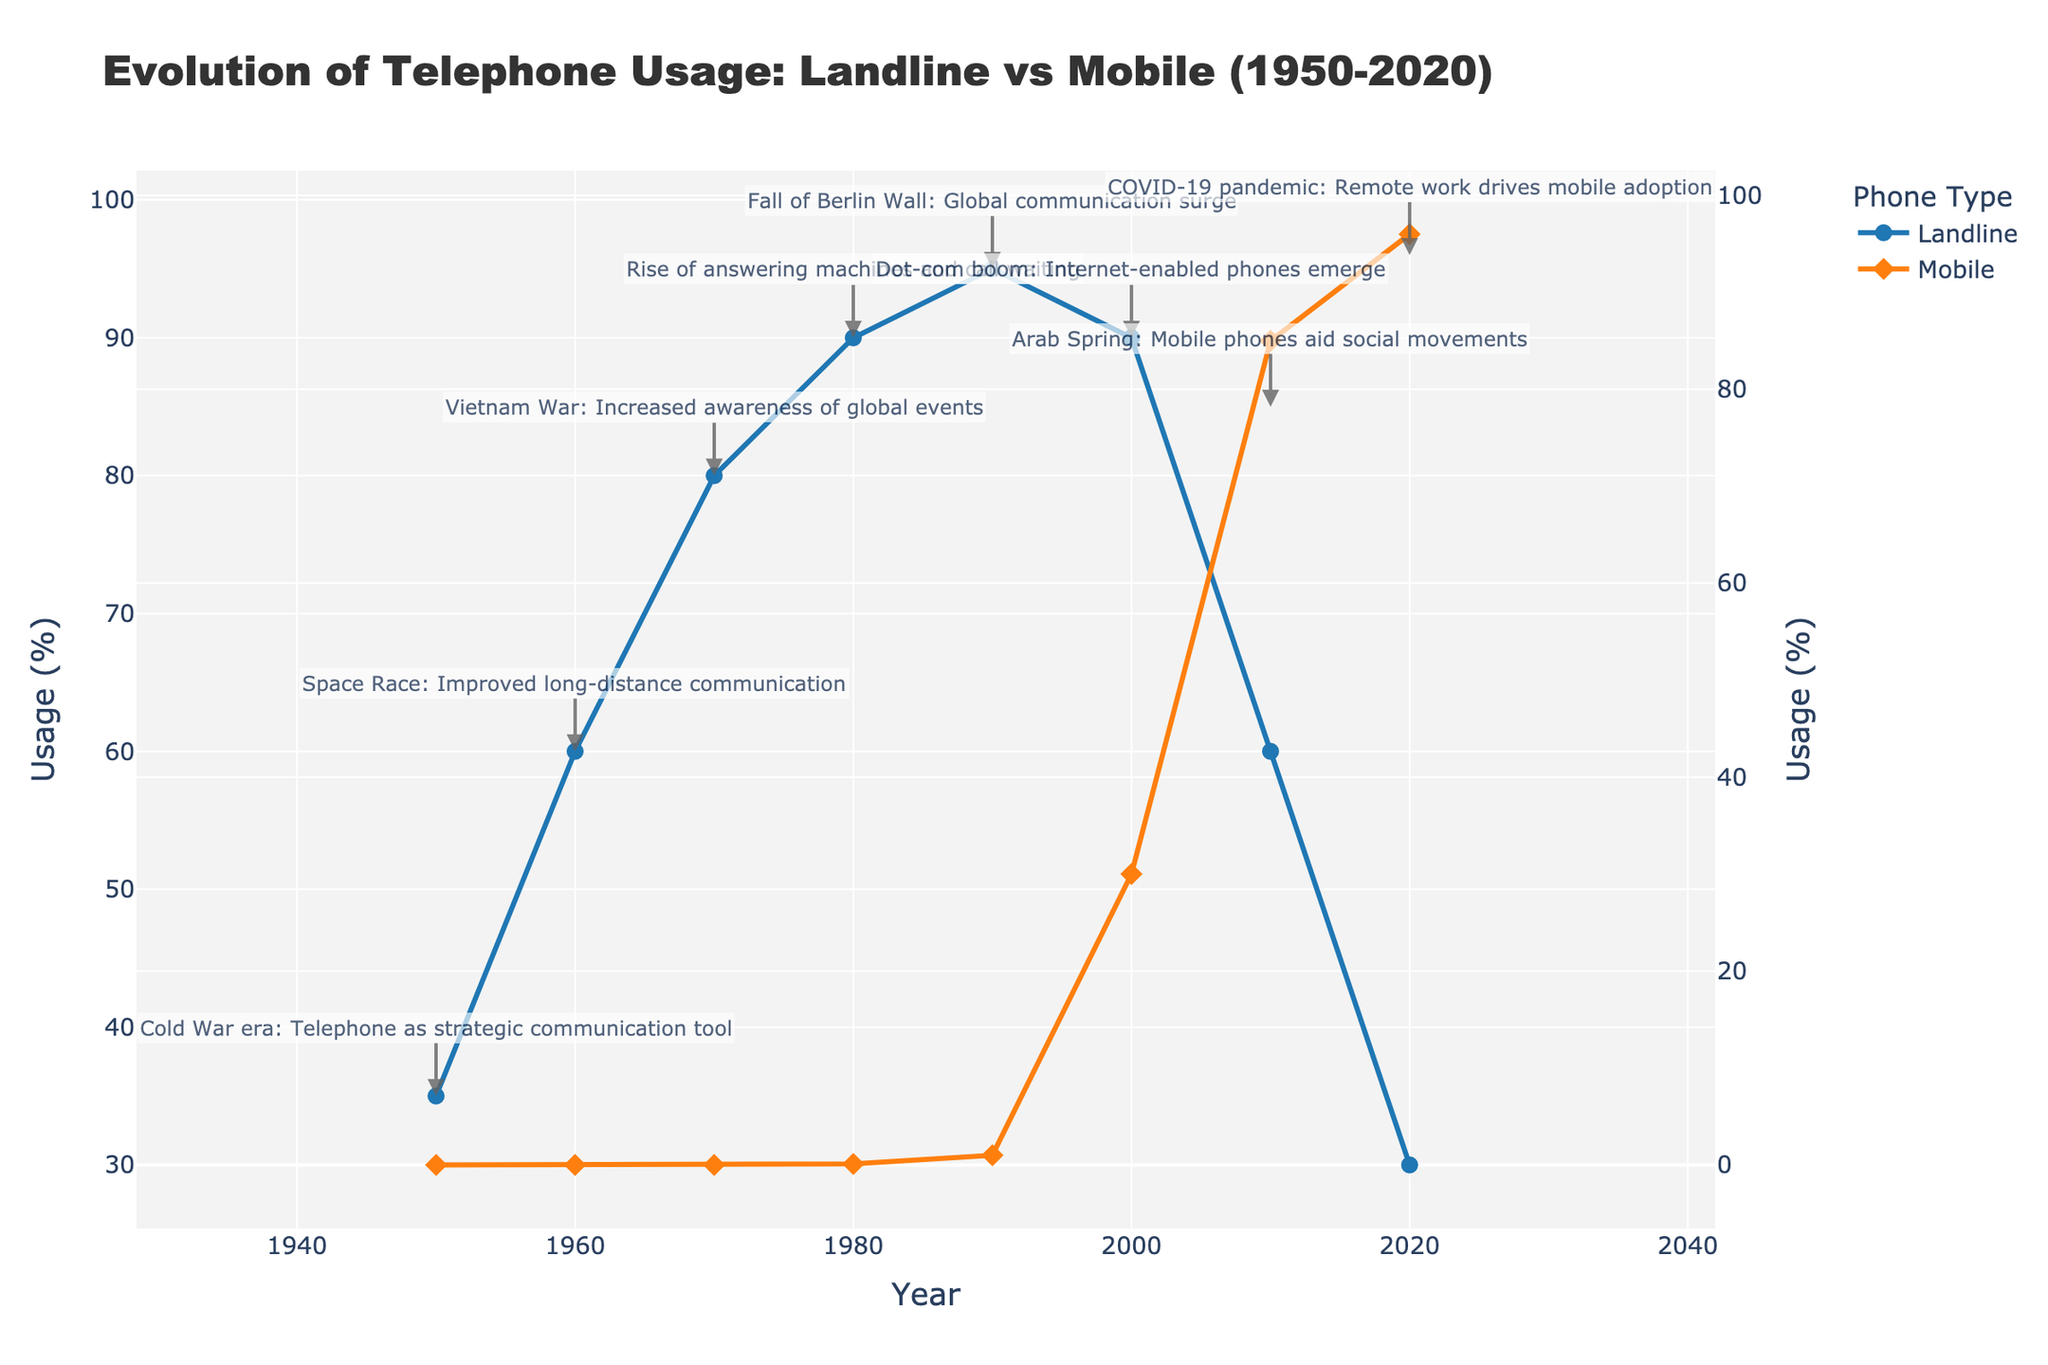What year did mobile usage first surpass landline usage? According to the figure, mobile usage first exceeds landline usage in the year where their lines cross. By observing the lines, this happens in 2010.
Answer: 2010 During which decade did landline usage reach its peak, and what was the peak percentage? The landline usage shows its highest point on the chart in 1990, reaching a peak percentage of 95%.
Answer: 1990, 95% Compare mobile usage in 2000 to landline usage in 1960. Which was higher, and by how much? In 2000, mobile usage was 30%, while landline usage in 1960 was 60%. Landline usage in 1960 was higher by 30%.
Answer: Landline in 1960, 30% What historical event is noted during the highest recorded landline usage? The peak of landline usage at 95% in 1990 coincides with the historical note: "Fall of Berlin Wall: Global communication surge".
Answer: Fall of Berlin Wall Between 1980 and 2020, which decade shows the largest increase in mobile usage, and by what percentage did it increase? By examining the increments in mobile usage by decade: 1980 (0.1%) to 1990 (1%) is 0.9%, 1990 to 2000 (30%) is 29%, 2000 to 2010 (85%) is 55%, and 2010 to 2020 (96%) is 11. The largest increase is from 2000 to 2010, which is 55%.
Answer: 2000 to 2010, 55% By how much did landline usage decrease from 2010 to 2020? In 2010, landline usage was at 60%, and in 2020 it dropped to 30%. The decrease is 60% - 30% = 30%.
Answer: 30% What is the significance of mobile phone adoption in 2010 as related to the historical note, and how does it compare visually to the previous decade? In 2010, the historical note is "Arab Spring: Mobile phones aid social movements". Mobile usage jumped significantly from 30% in 2000 to 85% in 2010, visually represented by a steep increase in the mobile usage line.
Answer: Significant increase due to Arab Spring What was the percentage difference between landline and mobile usage in 2020? In 2020, landline usage was 30% and mobile usage was 96%. The difference is 96% - 30% = 66%.
Answer: 66% Identify one decade where both landline and mobile usage were increasing. What might have contributed to this trend historically? During the 1990s, both landline (90% to 95%) and mobile (0.1% to 1%) usage increased. The historical note mentions the fall of the Berlin Wall, which facilitated a surge in global communication.
Answer: 1990s, Fall of Berlin Wall 